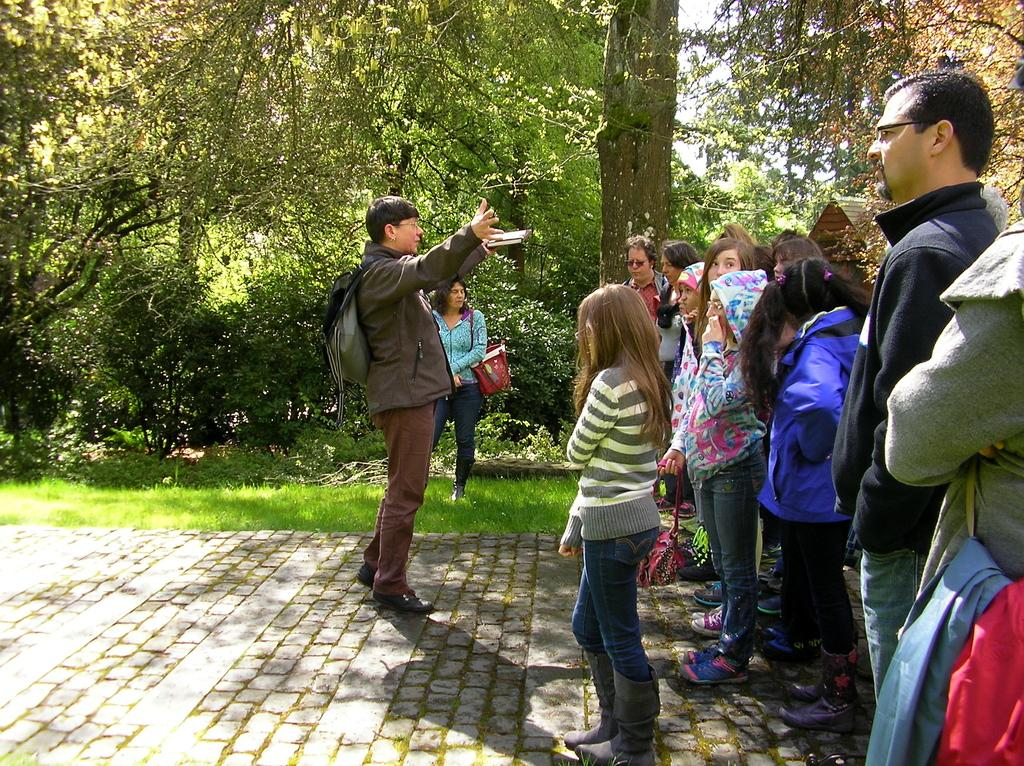What are the people in the image doing? The people in the image are standing on the pavement. What are some of the people carrying? Some of the people are carrying bags. What type of vegetation can be seen in the image? There are plants, trees, and grass in the image. What is visible in the background of the image? The sky is visible in the image. What type of pencil is being used by the judge in the image? There is no judge or pencil present in the image. What color is the canvas that the people are standing on in the image? There is no canvas in the image; the people are standing on pavement. 